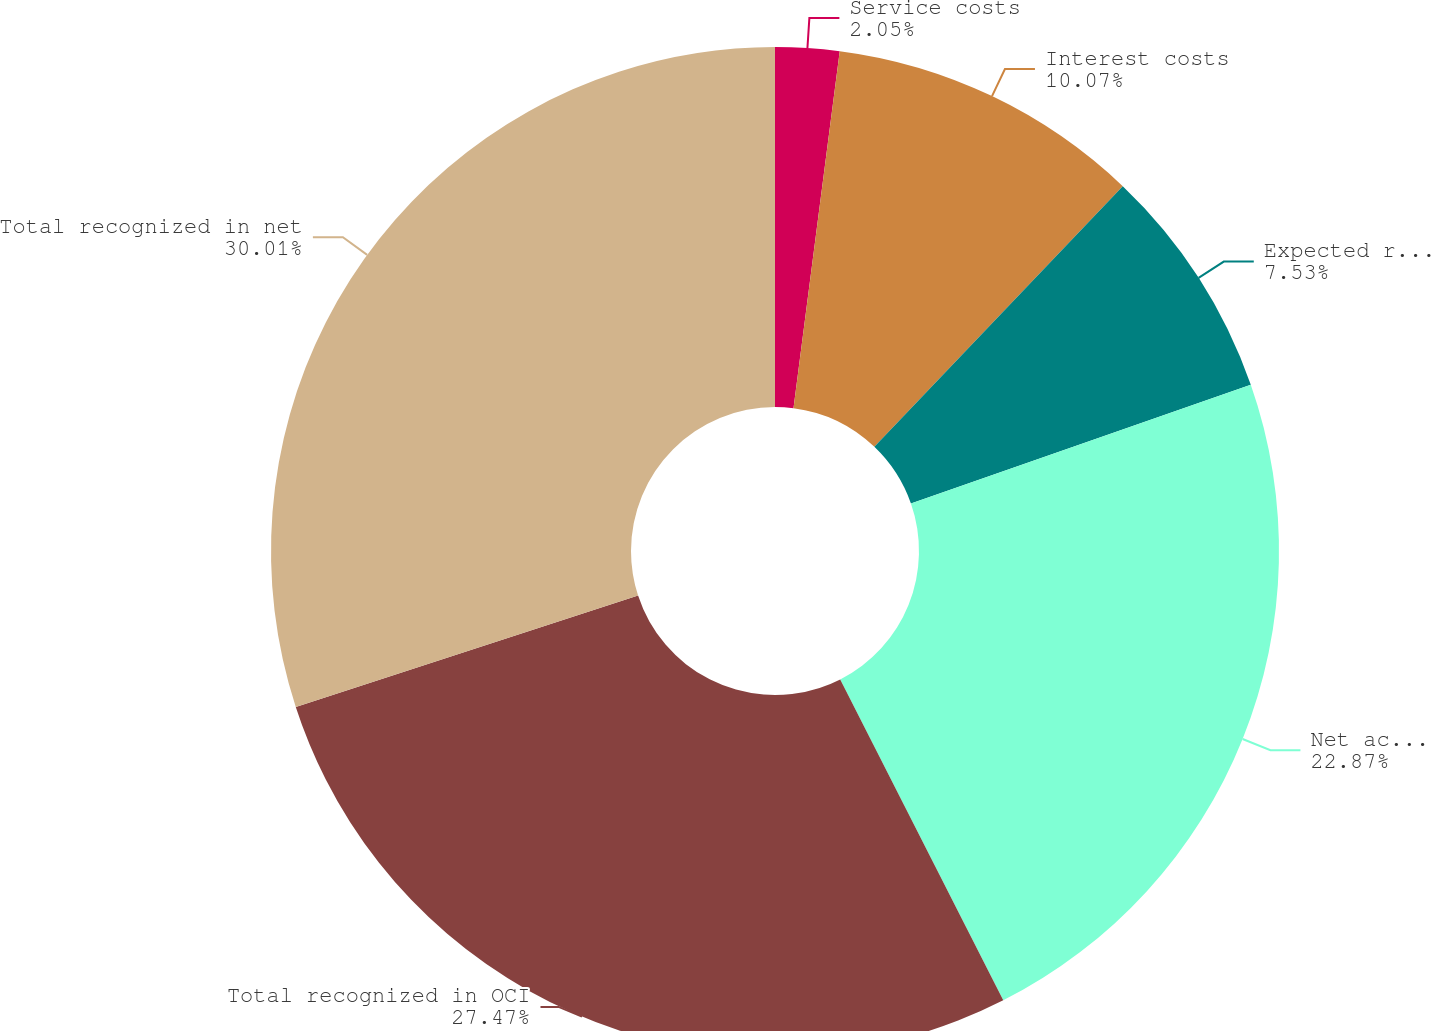Convert chart to OTSL. <chart><loc_0><loc_0><loc_500><loc_500><pie_chart><fcel>Service costs<fcel>Interest costs<fcel>Expected return on plan assets<fcel>Net actuarial (gains) losses<fcel>Total recognized in OCI<fcel>Total recognized in net<nl><fcel>2.05%<fcel>10.07%<fcel>7.53%<fcel>22.87%<fcel>27.47%<fcel>30.01%<nl></chart> 